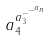Convert formula to latex. <formula><loc_0><loc_0><loc_500><loc_500>a _ { 4 } ^ { a _ { 3 } ^ { - ^ { - ^ { a _ { n } } } } }</formula> 